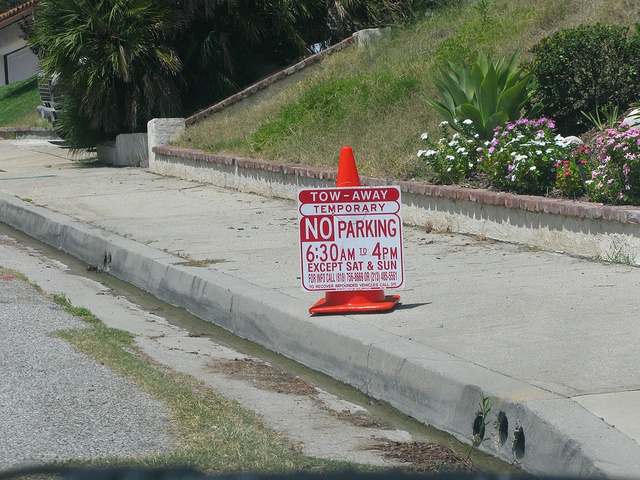Describe the objects in this image and their specific colors. I can see car in black, gray, darkgray, and darkgreen tones and truck in black, gray, darkgray, and purple tones in this image. 